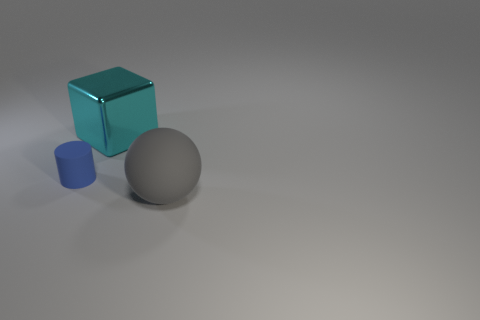Is there any other thing that is the same size as the blue cylinder?
Keep it short and to the point. No. Is there anything else that is the same shape as the small object?
Ensure brevity in your answer.  No. Is there anything else that is made of the same material as the cube?
Offer a terse response. No. What shape is the thing that is left of the gray rubber sphere and on the right side of the tiny cylinder?
Keep it short and to the point. Cube. What is the block made of?
Provide a short and direct response. Metal. What number of cylinders are big gray objects or cyan shiny things?
Your answer should be very brief. 0. Does the big gray ball have the same material as the tiny blue object?
Give a very brief answer. Yes. What is the object that is to the right of the small object and left of the big rubber sphere made of?
Your response must be concise. Metal. Are there the same number of big cyan metallic objects left of the small blue object and purple spheres?
Your answer should be compact. Yes. How many things are either things behind the large matte sphere or balls?
Make the answer very short. 3. 